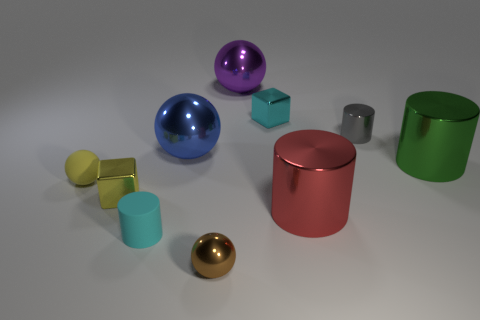The object that is both behind the green shiny object and on the left side of the tiny brown shiny sphere is what color?
Your answer should be very brief. Blue. Does the cyan object that is right of the large blue metallic thing have the same size as the metallic thing in front of the cyan rubber cylinder?
Your answer should be compact. Yes. What number of other things are the same color as the tiny rubber ball?
Provide a short and direct response. 1. Is the color of the tiny metallic sphere the same as the tiny metallic cylinder?
Your answer should be compact. No. How big is the ball on the right side of the small sphere on the right side of the small cyan matte thing?
Ensure brevity in your answer.  Large. Does the blue thing that is on the right side of the small matte sphere have the same material as the small brown sphere to the right of the tiny cyan cylinder?
Provide a succinct answer. Yes. Do the tiny matte thing that is behind the red object and the matte cylinder have the same color?
Offer a very short reply. No. There is a large green shiny thing; how many tiny yellow balls are to the right of it?
Provide a short and direct response. 0. Is the big red cylinder made of the same material as the object behind the small cyan block?
Provide a short and direct response. Yes. There is a brown thing that is the same material as the large green thing; what is its size?
Keep it short and to the point. Small. 